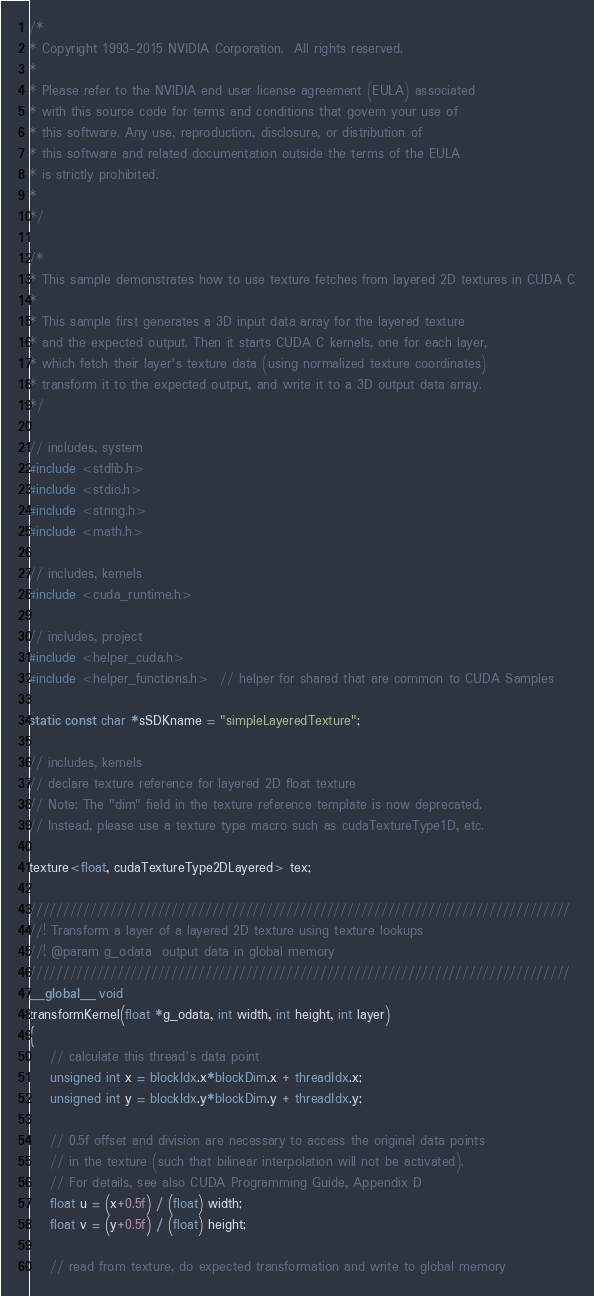<code> <loc_0><loc_0><loc_500><loc_500><_Cuda_>/*
* Copyright 1993-2015 NVIDIA Corporation.  All rights reserved.
*
* Please refer to the NVIDIA end user license agreement (EULA) associated
* with this source code for terms and conditions that govern your use of
* this software. Any use, reproduction, disclosure, or distribution of
* this software and related documentation outside the terms of the EULA
* is strictly prohibited.
*
*/

/*
* This sample demonstrates how to use texture fetches from layered 2D textures in CUDA C
*
* This sample first generates a 3D input data array for the layered texture
* and the expected output. Then it starts CUDA C kernels, one for each layer,
* which fetch their layer's texture data (using normalized texture coordinates)
* transform it to the expected output, and write it to a 3D output data array.
*/

// includes, system
#include <stdlib.h>
#include <stdio.h>
#include <string.h>
#include <math.h>

// includes, kernels
#include <cuda_runtime.h>

// includes, project
#include <helper_cuda.h>
#include <helper_functions.h>  // helper for shared that are common to CUDA Samples

static const char *sSDKname = "simpleLayeredTexture";

// includes, kernels
// declare texture reference for layered 2D float texture
// Note: The "dim" field in the texture reference template is now deprecated.
// Instead, please use a texture type macro such as cudaTextureType1D, etc.

texture<float, cudaTextureType2DLayered> tex;

////////////////////////////////////////////////////////////////////////////////
//! Transform a layer of a layered 2D texture using texture lookups
//! @param g_odata  output data in global memory
////////////////////////////////////////////////////////////////////////////////
__global__ void
transformKernel(float *g_odata, int width, int height, int layer)
{
    // calculate this thread's data point
    unsigned int x = blockIdx.x*blockDim.x + threadIdx.x;
    unsigned int y = blockIdx.y*blockDim.y + threadIdx.y;

    // 0.5f offset and division are necessary to access the original data points
    // in the texture (such that bilinear interpolation will not be activated).
    // For details, see also CUDA Programming Guide, Appendix D
    float u = (x+0.5f) / (float) width;
    float v = (y+0.5f) / (float) height;

    // read from texture, do expected transformation and write to global memory</code> 